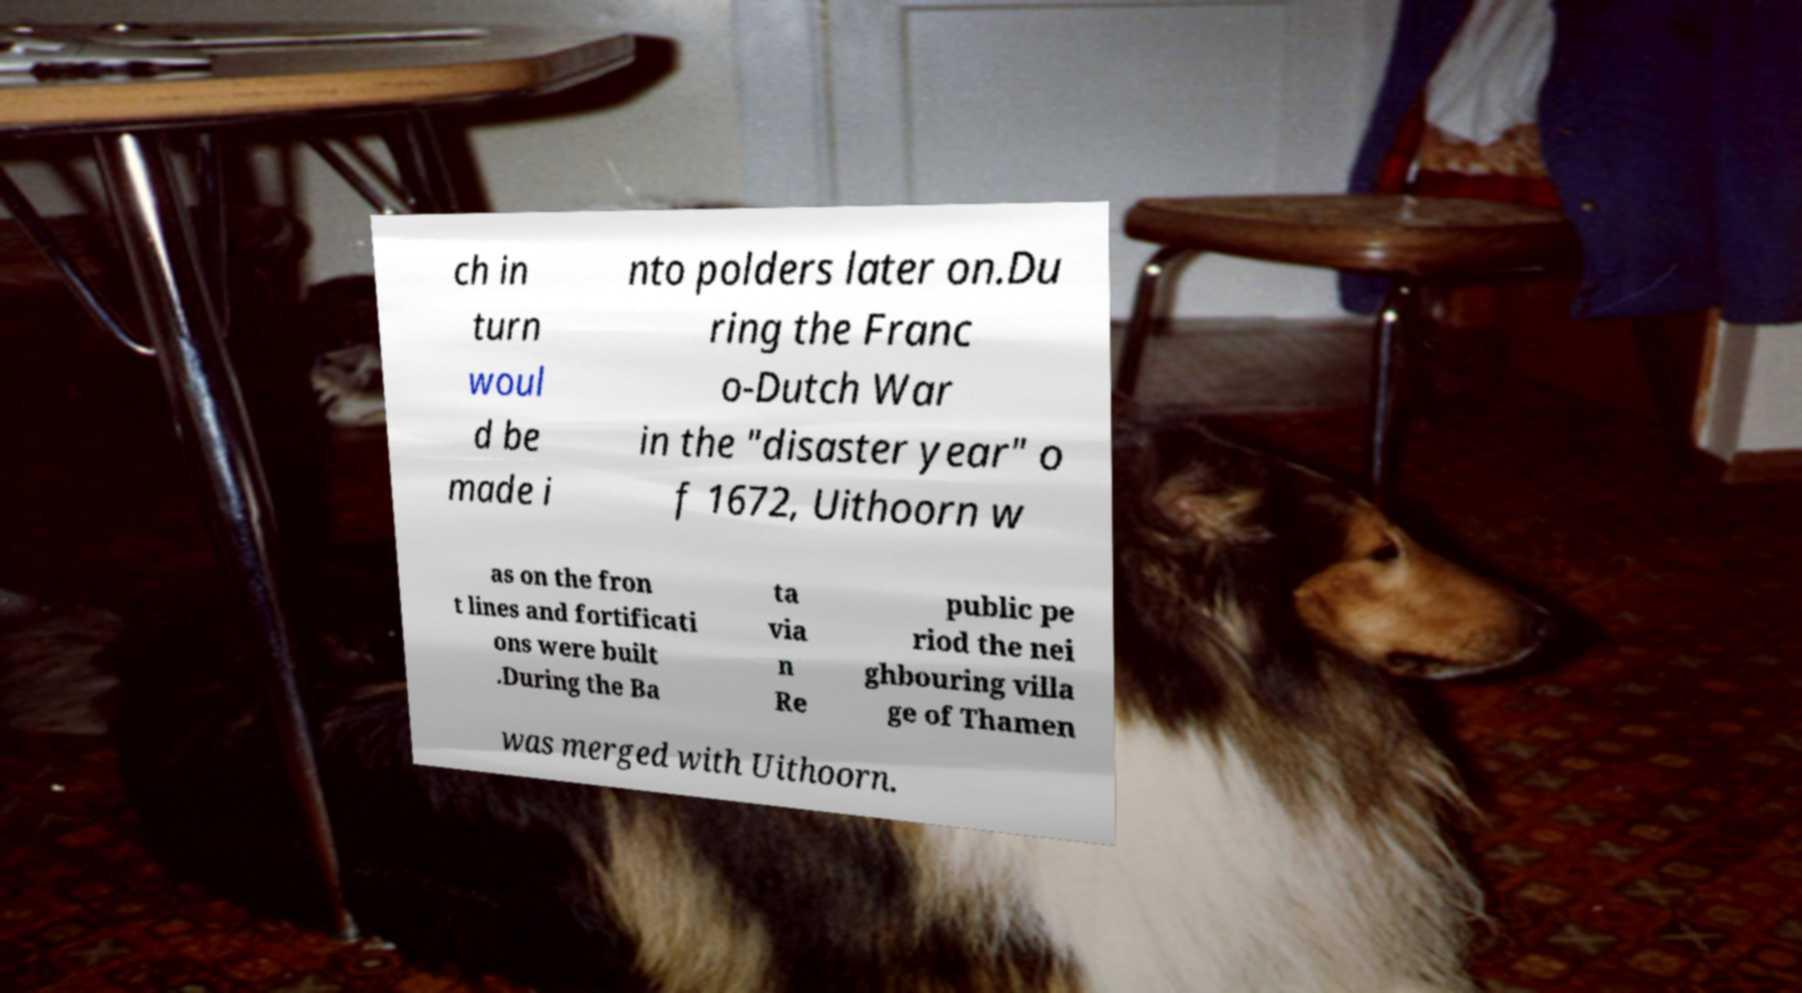I need the written content from this picture converted into text. Can you do that? ch in turn woul d be made i nto polders later on.Du ring the Franc o-Dutch War in the "disaster year" o f 1672, Uithoorn w as on the fron t lines and fortificati ons were built .During the Ba ta via n Re public pe riod the nei ghbouring villa ge of Thamen was merged with Uithoorn. 